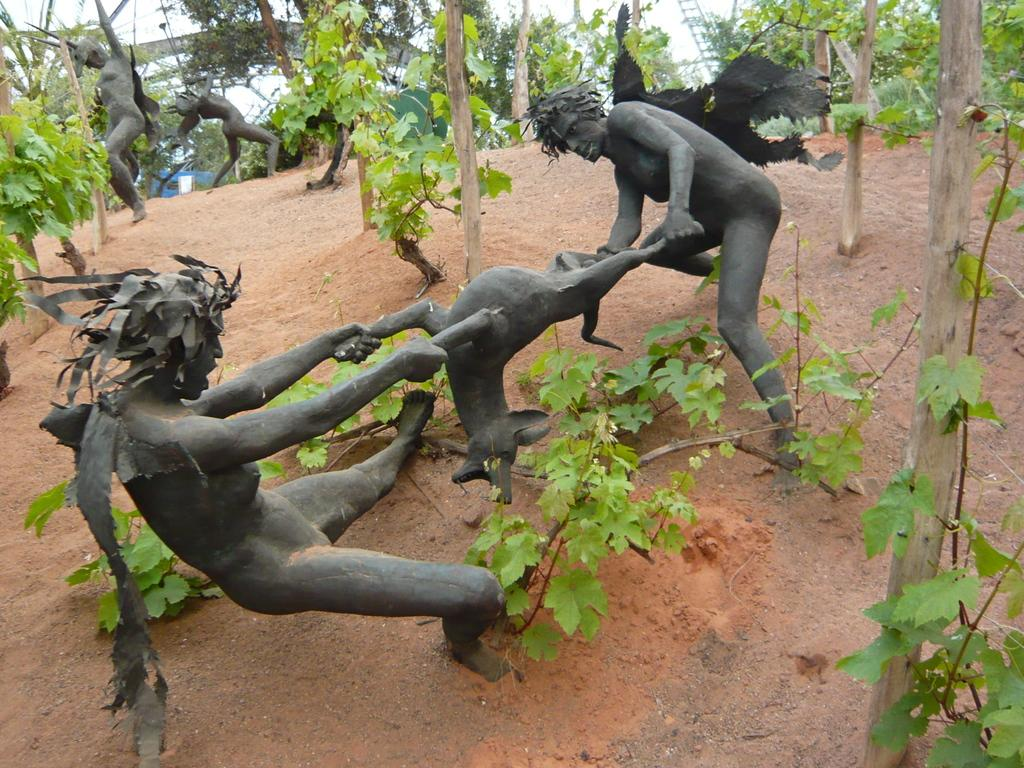What type of sculptures can be seen in the image? There are black sculptures of people and animals in the image. What else is present in the image besides the sculptures? There are plants around the sculptures. Is the sculpture of a person sinking in quicksand in the image? There is no quicksand present in the image, and the sculptures are not depicted as sinking. 